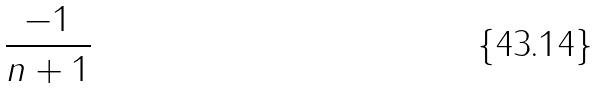Convert formula to latex. <formula><loc_0><loc_0><loc_500><loc_500>\frac { - 1 } { n + 1 }</formula> 